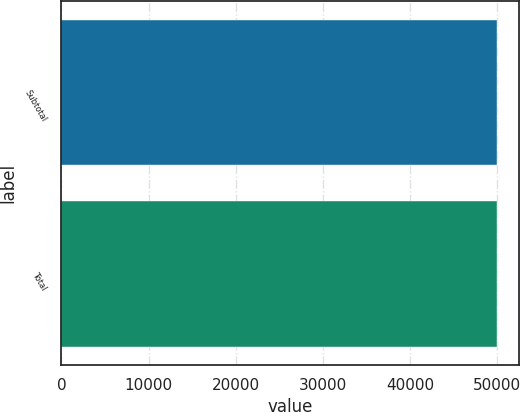Convert chart to OTSL. <chart><loc_0><loc_0><loc_500><loc_500><bar_chart><fcel>Subtotal<fcel>Total<nl><fcel>50000<fcel>50000.1<nl></chart> 